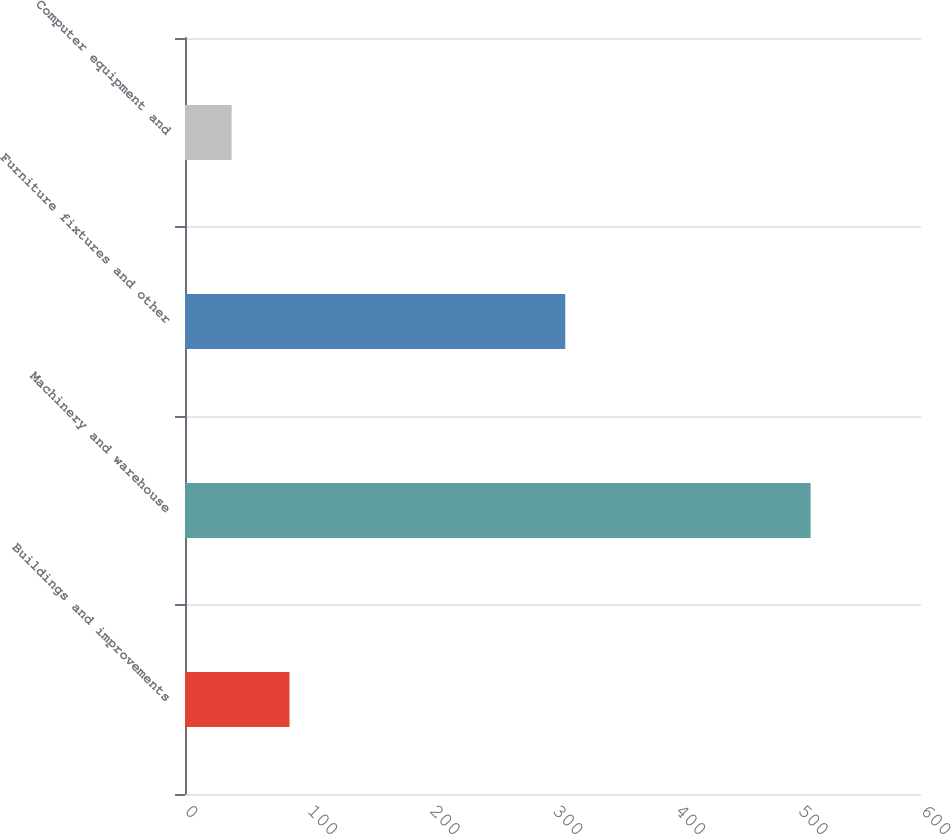Convert chart. <chart><loc_0><loc_0><loc_500><loc_500><bar_chart><fcel>Buildings and improvements<fcel>Machinery and warehouse<fcel>Furniture fixtures and other<fcel>Computer equipment and<nl><fcel>85.2<fcel>510<fcel>310<fcel>38<nl></chart> 